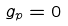<formula> <loc_0><loc_0><loc_500><loc_500>g _ { p } = 0</formula> 